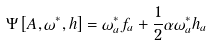Convert formula to latex. <formula><loc_0><loc_0><loc_500><loc_500>\Psi \left [ A , \omega ^ { * } , h \right ] = \omega ^ { * } _ { a } f _ { a } + \frac { 1 } { 2 } \alpha \omega ^ { * } _ { a } h _ { a }</formula> 